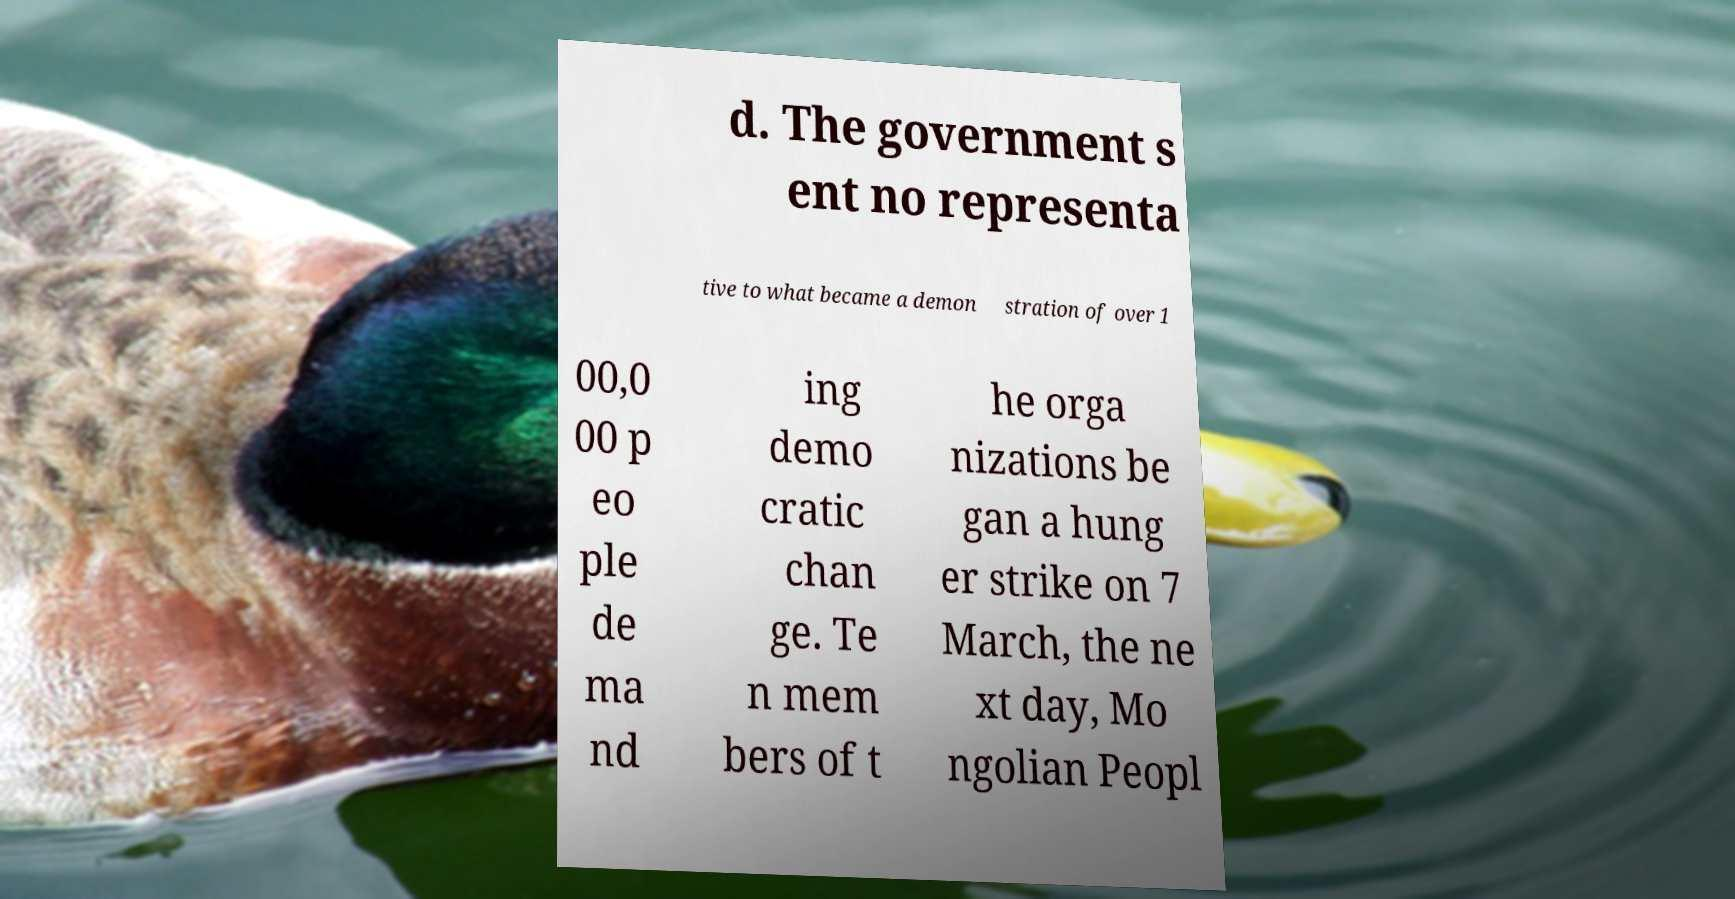Could you extract and type out the text from this image? d. The government s ent no representa tive to what became a demon stration of over 1 00,0 00 p eo ple de ma nd ing demo cratic chan ge. Te n mem bers of t he orga nizations be gan a hung er strike on 7 March, the ne xt day, Mo ngolian Peopl 